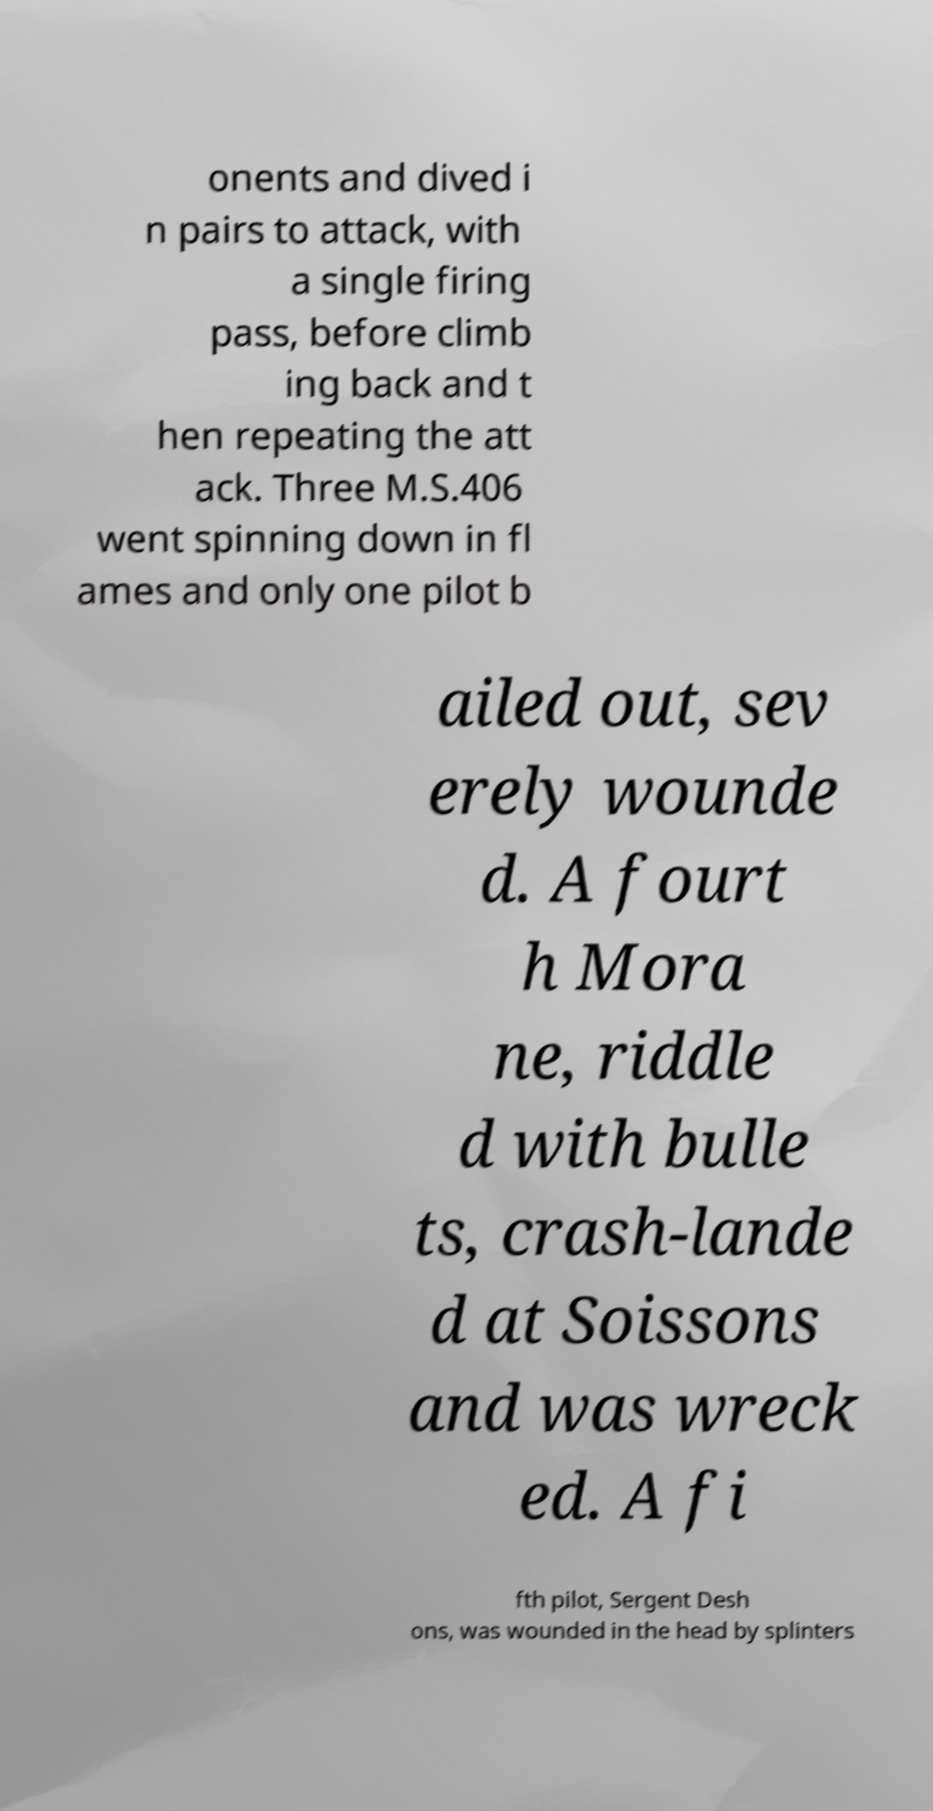Could you assist in decoding the text presented in this image and type it out clearly? onents and dived i n pairs to attack, with a single firing pass, before climb ing back and t hen repeating the att ack. Three M.S.406 went spinning down in fl ames and only one pilot b ailed out, sev erely wounde d. A fourt h Mora ne, riddle d with bulle ts, crash-lande d at Soissons and was wreck ed. A fi fth pilot, Sergent Desh ons, was wounded in the head by splinters 